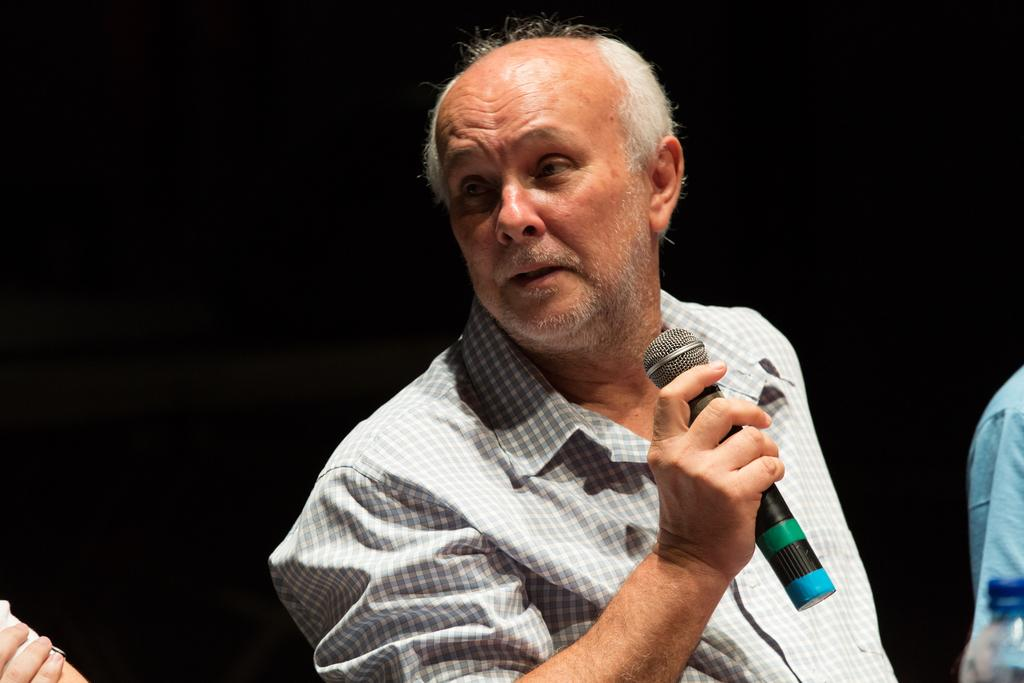Who is the main subject in the image? There is a man in the image. What is the man holding in his hand? The man is holding a mic in his hand. What is the man doing with the mic? The man is talking to other persons. What is the color of the background in the image? The background of the image is dark. What type of poison is being discussed by the man in the image? There is no mention of poison in the image; the man is holding a mic and talking to other persons. How many clocks can be seen in the image? There are no clocks visible in the image. 